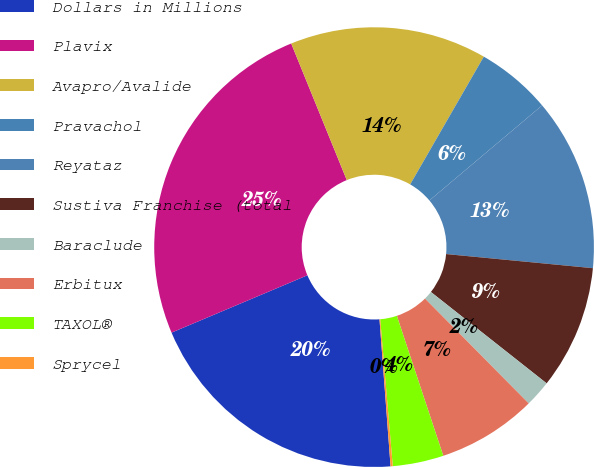Convert chart to OTSL. <chart><loc_0><loc_0><loc_500><loc_500><pie_chart><fcel>Dollars in Millions<fcel>Plavix<fcel>Avapro/Avalide<fcel>Pravachol<fcel>Reyataz<fcel>Sustiva Franchise (total<fcel>Baraclude<fcel>Erbitux<fcel>TAXOL®<fcel>Sprycel<nl><fcel>19.84%<fcel>25.21%<fcel>14.47%<fcel>5.53%<fcel>12.68%<fcel>9.11%<fcel>1.95%<fcel>7.32%<fcel>3.74%<fcel>0.16%<nl></chart> 